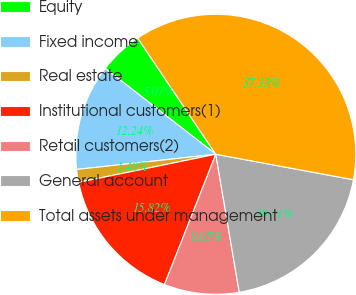Convert chart. <chart><loc_0><loc_0><loc_500><loc_500><pie_chart><fcel>Equity<fcel>Fixed income<fcel>Real estate<fcel>Institutional customers(1)<fcel>Retail customers(2)<fcel>General account<fcel>Total assets under management<nl><fcel>5.07%<fcel>12.24%<fcel>1.48%<fcel>15.82%<fcel>8.65%<fcel>19.41%<fcel>37.33%<nl></chart> 